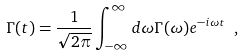Convert formula to latex. <formula><loc_0><loc_0><loc_500><loc_500>\Gamma ( t ) = \frac { 1 } { \sqrt { 2 \pi } } \int _ { - \infty } ^ { \infty } d \omega \Gamma ( \omega ) e ^ { - i \omega t } \ ,</formula> 